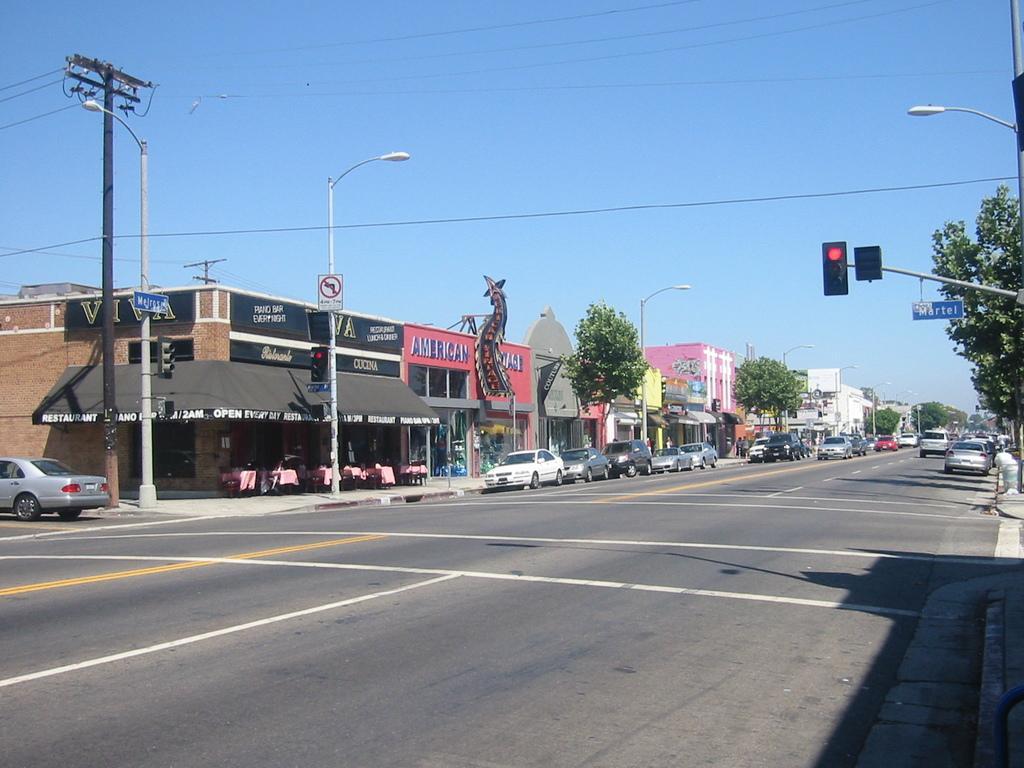Please provide a concise description of this image. In the foreground it is road. On the right there are cars, trees, signal light and street light. In the center of the picture there are cars, trees, buildings, street lights and buildings. On the left there are street lights, current pole, cables, building, tables, chairs, car and footpath. In the background it is sky. 